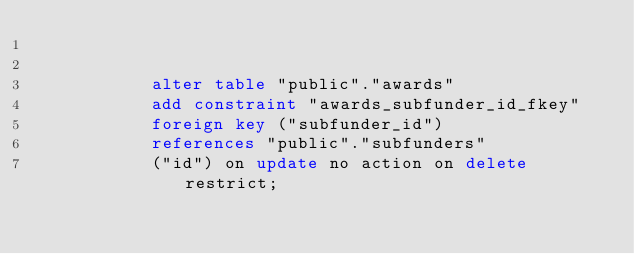<code> <loc_0><loc_0><loc_500><loc_500><_SQL_>

           alter table "public"."awards"
           add constraint "awards_subfunder_id_fkey"
           foreign key ("subfunder_id")
           references "public"."subfunders"
           ("id") on update no action on delete restrict;
      </code> 